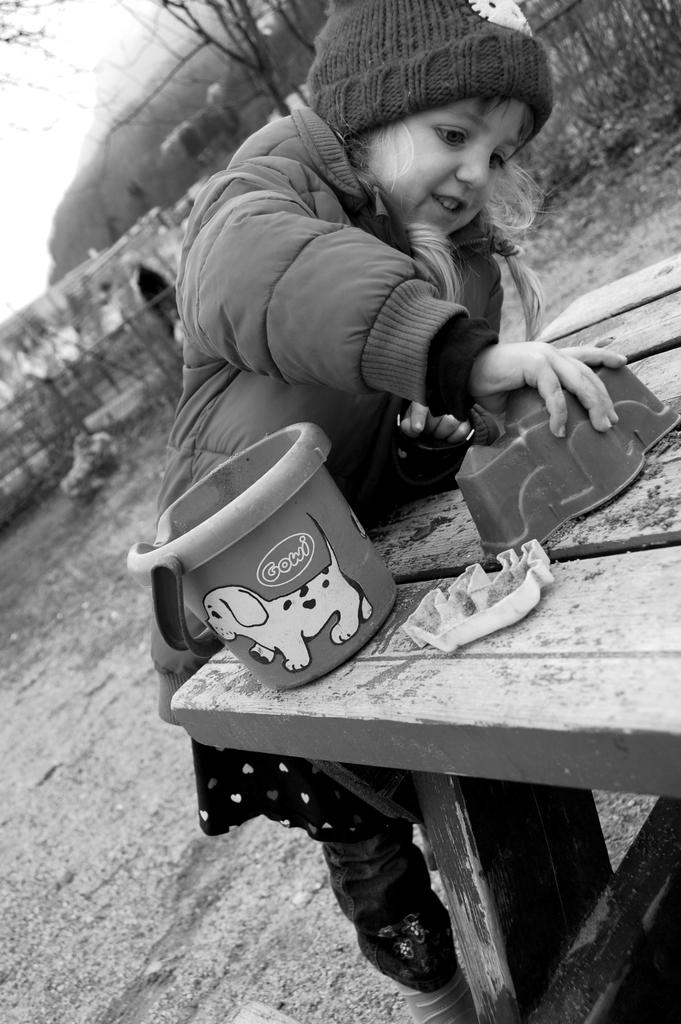What is the main subject of the image? There is a child in the image. What is the child doing in the image? The child is standing in the image. What is in front of the child? There is a bench in front of the child. What object can be seen near the child? There is a bucket in the image. What type of clothing is the child wearing? The child is wearing a jacket and a cap. What can be seen in the background of the image? There is a tree in the image. What type of dress is the child wearing in the image? The child is not wearing a dress in the image; they are wearing a jacket and a cap. Can you tell me how many breaths the child takes in the image? The child's breathing is not visible or measurable in the image. 